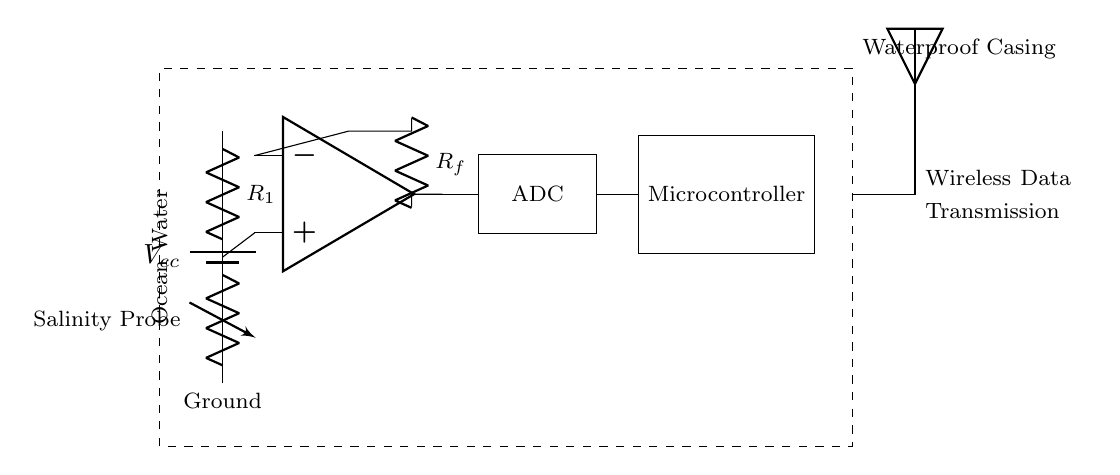What component is used to measure salinity? The salinity probe is the component that directly measures the salinity of the ocean water. This is indicated by the label on the variable resistor in the circuit.
Answer: Salinity Probe What type of component is represented by the op-amp? The op-amp is a type of integrated circuit used for amplifying voltage signals. In this diagram, it amplifies the signal from the salinity probe to make it suitable for further processing.
Answer: Integrated Circuit What is the purpose of the voltage divider? The voltage divider, consisting of the fixed resistor and the salinity probe, functions to lower the voltage signal to a manageable level for the op-amp. This allows the op-amp to operate effectively within its input range.
Answer: Lowering voltage What type of data transmission method is used in the circuit? The circuit employs wireless data transmission, which is designed for remotely sending the salinity readings obtained from the microcontroller to an external system or device through an antenna.
Answer: Wireless How does the microcontroller interact with the ADC? The microcontroller receives the converted digital signal from the ADC, which is responsible for converting the analog output from the op-amp into a digital signal that can be processed by the microcontroller. This is crucial for the functionality of the device in data collection.
Answer: Receives digital signal What is the purpose of the waterproof casing? The waterproof casing provides protection for the entire circuit and components from the ocean environment, ensuring that they can function reliably despite exposure to water. This is vital for conducting marine data collection without damage.
Answer: Protection What is the resistance value of the feedback resistor? The feedback resistor, labeled R_f in the circuit, plays a critical role in determining the gain of the op-amp, although its specific value isn't provided in this diagram, it would need to match the required gain for the desired amplification of the salinity signal.
Answer: Feedback resistor value needed 